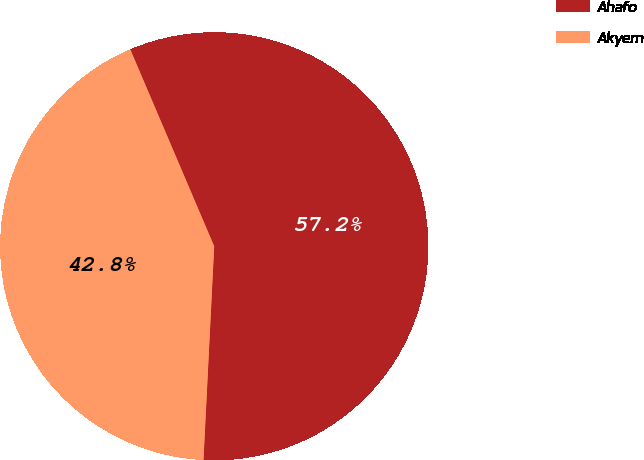Convert chart to OTSL. <chart><loc_0><loc_0><loc_500><loc_500><pie_chart><fcel>Ahafo<fcel>Akyem<nl><fcel>57.21%<fcel>42.79%<nl></chart> 